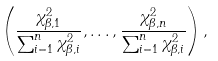<formula> <loc_0><loc_0><loc_500><loc_500>\left ( \frac { \chi _ { \beta , 1 } ^ { 2 } } { \sum _ { i = 1 } ^ { n } \chi _ { \beta , i } ^ { 2 } } , \dots , \frac { \chi _ { \beta , n } ^ { 2 } } { \sum _ { i = 1 } ^ { n } \chi _ { \beta , i } ^ { 2 } } \right ) ,</formula> 